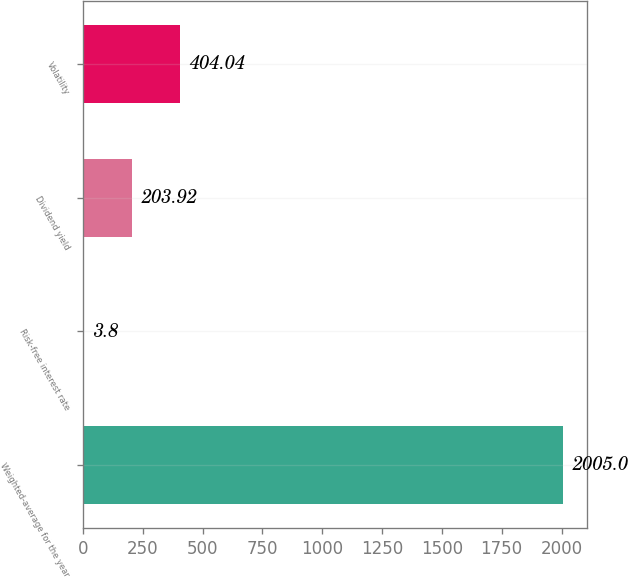Convert chart to OTSL. <chart><loc_0><loc_0><loc_500><loc_500><bar_chart><fcel>Weighted-average for the year<fcel>Risk-free interest rate<fcel>Dividend yield<fcel>Volatility<nl><fcel>2005<fcel>3.8<fcel>203.92<fcel>404.04<nl></chart> 